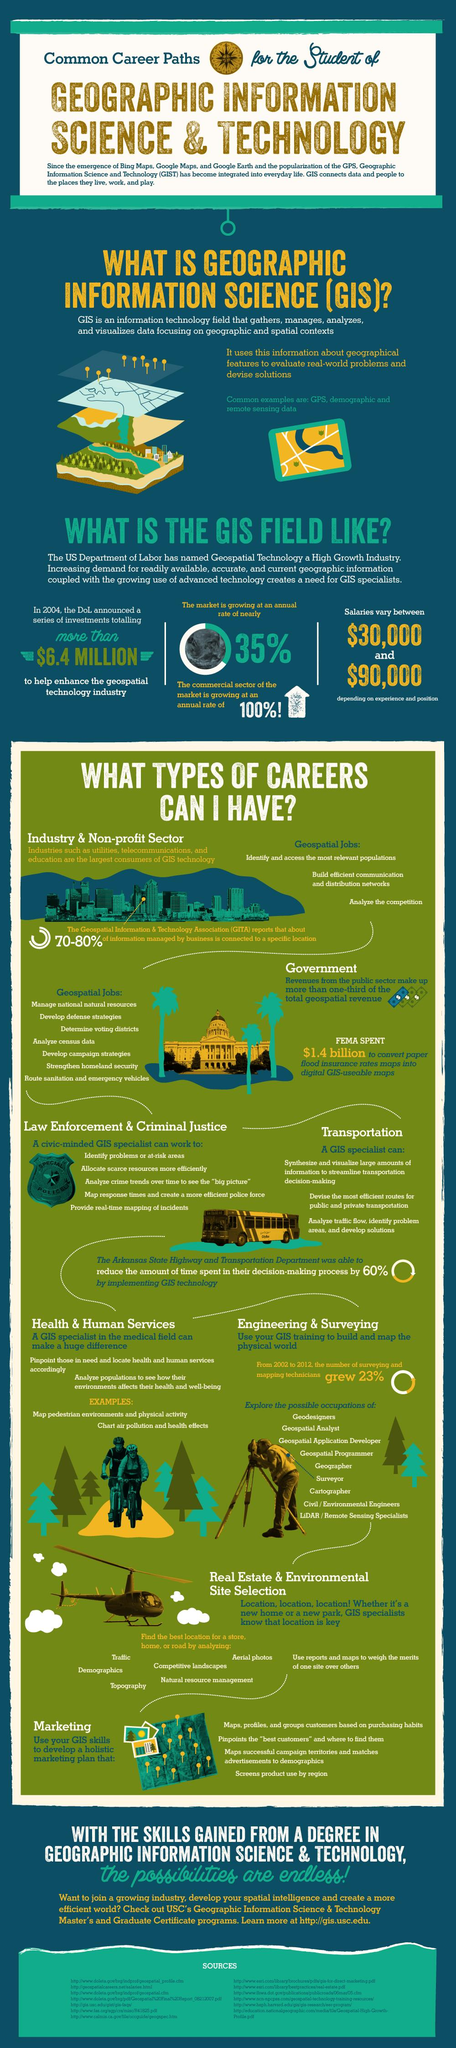Mention a couple of crucial points in this snapshot. A GIS specialist analyzes census data in the government sector. As a GIS specialist, I can analyze traffic flow, identify problem areas, and develop solutions in the transportation sector. GPS and remote sensing are examples of the field of geographic information science, which involves the collection, analysis, and interpretation of spatial data. As a GIS specialist working in the Law & Justice sector, I am responsible for performing various tasks that require the use of GIS technology. One of the functions I am capable of performing is allocating scarce resources more efficiently. This involves using spatial analysis and mapping techniques to identify areas of high need, optimize resource distribution, and improve resource utilization. GIS training can be used in the field of engineering and surveying to build and map the physical world. 